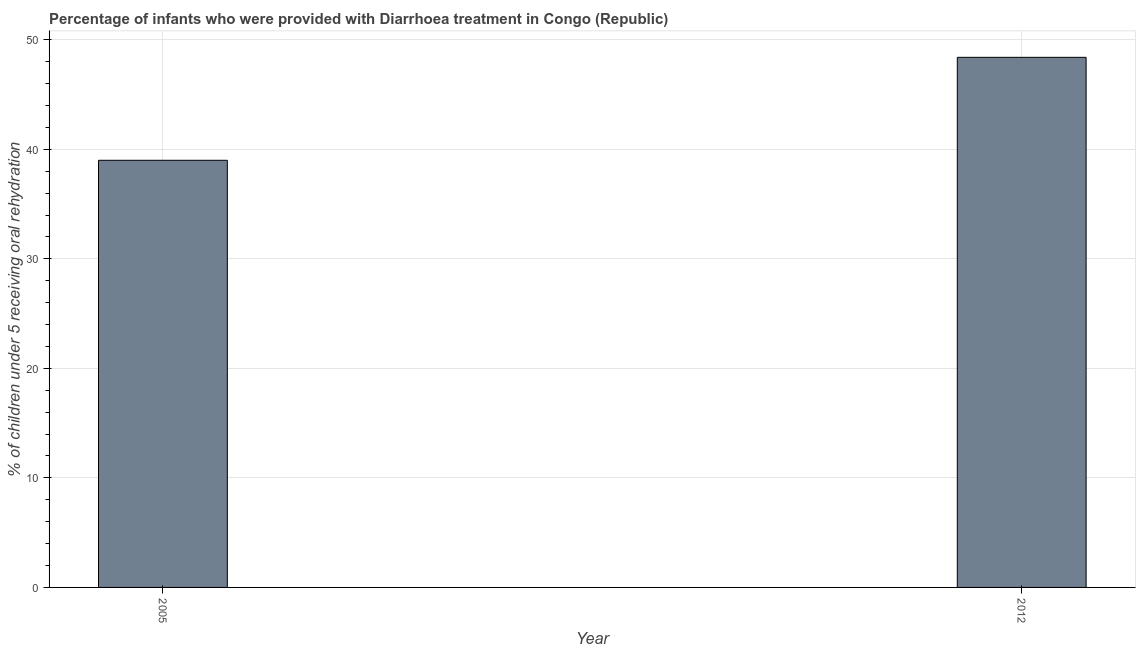What is the title of the graph?
Make the answer very short. Percentage of infants who were provided with Diarrhoea treatment in Congo (Republic). What is the label or title of the Y-axis?
Provide a short and direct response. % of children under 5 receiving oral rehydration. What is the percentage of children who were provided with treatment diarrhoea in 2012?
Your response must be concise. 48.4. Across all years, what is the maximum percentage of children who were provided with treatment diarrhoea?
Provide a short and direct response. 48.4. Across all years, what is the minimum percentage of children who were provided with treatment diarrhoea?
Offer a very short reply. 39. In which year was the percentage of children who were provided with treatment diarrhoea minimum?
Make the answer very short. 2005. What is the sum of the percentage of children who were provided with treatment diarrhoea?
Keep it short and to the point. 87.4. What is the difference between the percentage of children who were provided with treatment diarrhoea in 2005 and 2012?
Offer a very short reply. -9.4. What is the average percentage of children who were provided with treatment diarrhoea per year?
Provide a short and direct response. 43.7. What is the median percentage of children who were provided with treatment diarrhoea?
Keep it short and to the point. 43.7. In how many years, is the percentage of children who were provided with treatment diarrhoea greater than 12 %?
Offer a terse response. 2. Do a majority of the years between 2012 and 2005 (inclusive) have percentage of children who were provided with treatment diarrhoea greater than 8 %?
Offer a terse response. No. What is the ratio of the percentage of children who were provided with treatment diarrhoea in 2005 to that in 2012?
Your answer should be compact. 0.81. How many years are there in the graph?
Your answer should be compact. 2. What is the difference between two consecutive major ticks on the Y-axis?
Ensure brevity in your answer.  10. Are the values on the major ticks of Y-axis written in scientific E-notation?
Provide a short and direct response. No. What is the % of children under 5 receiving oral rehydration in 2005?
Offer a terse response. 39. What is the % of children under 5 receiving oral rehydration in 2012?
Give a very brief answer. 48.4. What is the ratio of the % of children under 5 receiving oral rehydration in 2005 to that in 2012?
Offer a very short reply. 0.81. 